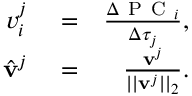Convert formula to latex. <formula><loc_0><loc_0><loc_500><loc_500>\begin{array} { r l r } { v _ { i } ^ { j } } & = } & { \frac { \Delta P C _ { i } } { \Delta \tau _ { j } } , } \\ { \hat { v } ^ { j } } & = } & { \frac { v ^ { j } } { | | v ^ { j } | | _ { 2 } } . } \end{array}</formula> 